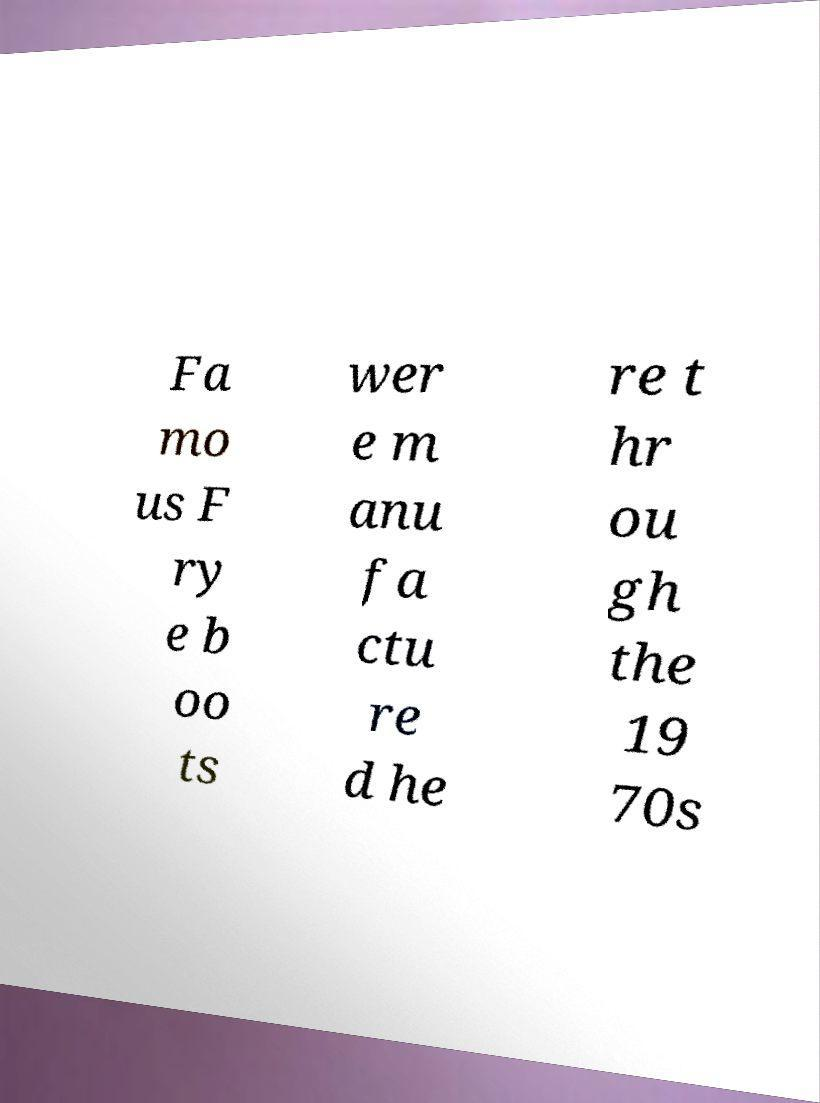Could you extract and type out the text from this image? Fa mo us F ry e b oo ts wer e m anu fa ctu re d he re t hr ou gh the 19 70s 